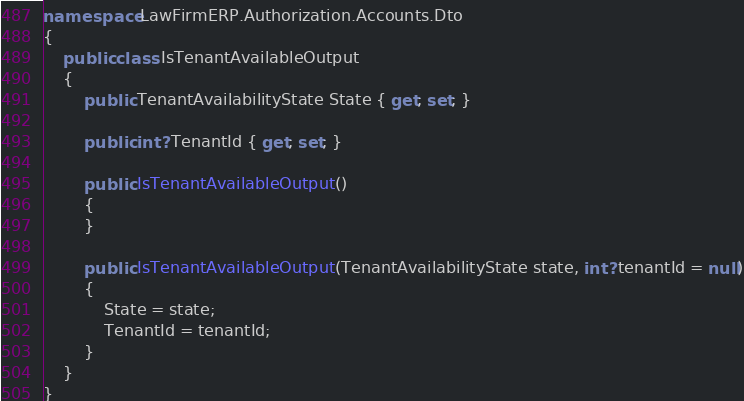<code> <loc_0><loc_0><loc_500><loc_500><_C#_>namespace LawFirmERP.Authorization.Accounts.Dto
{
    public class IsTenantAvailableOutput
    {
        public TenantAvailabilityState State { get; set; }

        public int? TenantId { get; set; }

        public IsTenantAvailableOutput()
        {
        }

        public IsTenantAvailableOutput(TenantAvailabilityState state, int? tenantId = null)
        {
            State = state;
            TenantId = tenantId;
        }
    }
}
</code> 